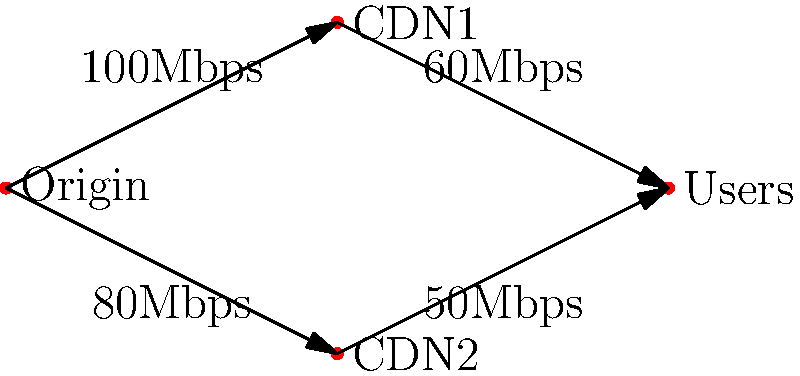Given the content delivery network (CDN) topology for distributing promotional videos of acrobatic acts, what is the maximum data flow rate from the Origin server to the Users, assuming each path can handle its labeled bandwidth simultaneously? To determine the maximum data flow rate from the Origin server to the Users, we need to follow these steps:

1. Identify the paths from Origin to Users:
   Path 1: Origin → CDN1 → Users
   Path 2: Origin → CDN2 → Users

2. Determine the bottleneck for each path:
   Path 1: Min(100Mbps, 60Mbps) = 60Mbps
   Path 2: Min(80Mbps, 50Mbps) = 50Mbps

3. Sum up the bottleneck capacities:
   Maximum flow = 60Mbps + 50Mbps = 110Mbps

This approach ensures we're utilizing the full capacity of both CDN servers simultaneously, which is crucial for efficiently distributing our acrobatic act videos to the widest possible audience. By leveraging both paths, we can achieve a higher total throughput than using just one path, allowing for faster content delivery and potentially reaching more viewers in less time.
Answer: 110Mbps 